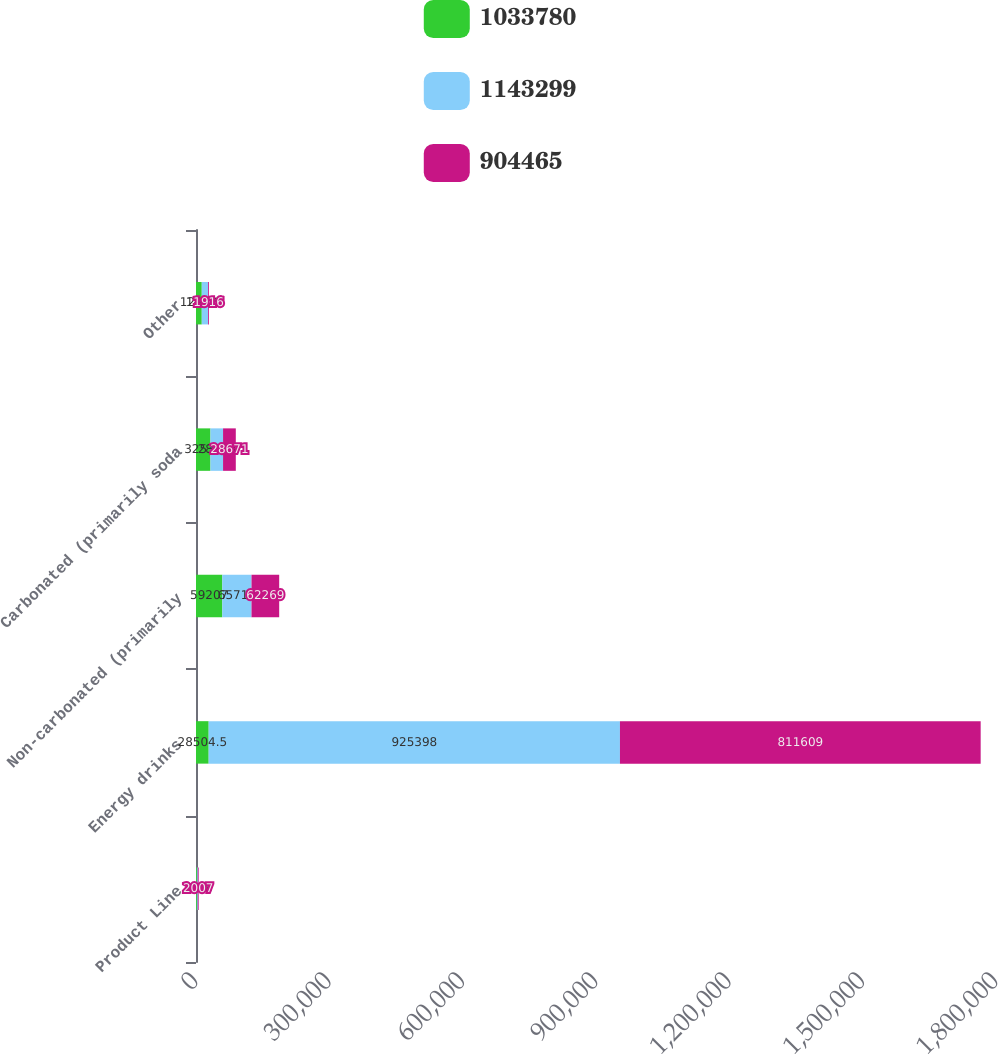Convert chart to OTSL. <chart><loc_0><loc_0><loc_500><loc_500><stacked_bar_chart><ecel><fcel>Product Line<fcel>Energy drinks<fcel>Non-carbonated (primarily<fcel>Carbonated (primarily soda<fcel>Other<nl><fcel>1.03378e+06<fcel>2009<fcel>28504.5<fcel>59207<fcel>32538<fcel>12982<nl><fcel>1.1433e+06<fcel>2008<fcel>925398<fcel>65713<fcel>28338<fcel>14331<nl><fcel>904465<fcel>2007<fcel>811609<fcel>62269<fcel>28671<fcel>1916<nl></chart> 